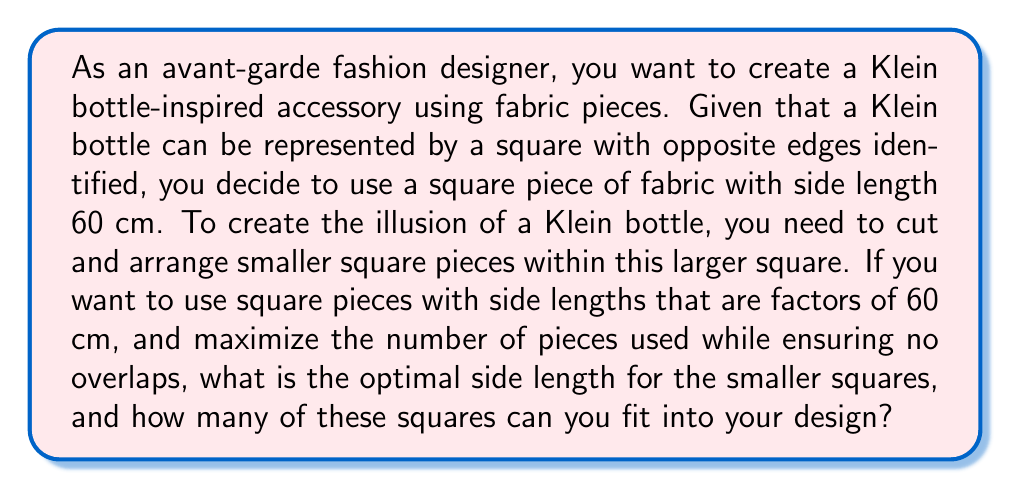Help me with this question. To solve this problem, we need to follow these steps:

1) First, let's list out the factors of 60 cm:
   Factors of 60 = 1, 2, 3, 4, 5, 6, 10, 12, 15, 20, 30, 60

2) We need to find the factor that will allow us to fit the maximum number of squares within our 60 cm x 60 cm fabric.

3) For each factor $f$, we can calculate the number of squares that would fit as:
   $n = (\frac{60}{f})^2$

4) Let's calculate this for each factor:

   For $f = 1$:  $n = 60^2 = 3600$
   For $f = 2$:  $n = 30^2 = 900$
   For $f = 3$:  $n = 20^2 = 400$
   For $f = 4$:  $n = 15^2 = 225$
   For $f = 5$:  $n = 12^2 = 144$
   For $f = 6$:  $n = 10^2 = 100$
   For $f = 10$: $n = 6^2 = 36$
   For $f = 12$: $n = 5^2 = 25$
   For $f = 15$: $n = 4^2 = 16$
   For $f = 20$: $n = 3^2 = 9$
   For $f = 30$: $n = 2^2 = 4$
   For $f = 60$: $n = 1^2 = 1$

5) The maximum number of squares is achieved when $f = 1$, which gives us 3600 squares. However, this might be impractical for a real-world design.

6) The next practical option would be $f = 2$, which gives us 900 squares of 2 cm x 2 cm each.

Therefore, the optimal side length for the smaller squares is 2 cm, and you can fit 900 of these squares into your design.
Answer: The optimal side length for the smaller squares is 2 cm, and you can fit 900 of these squares into your design. 